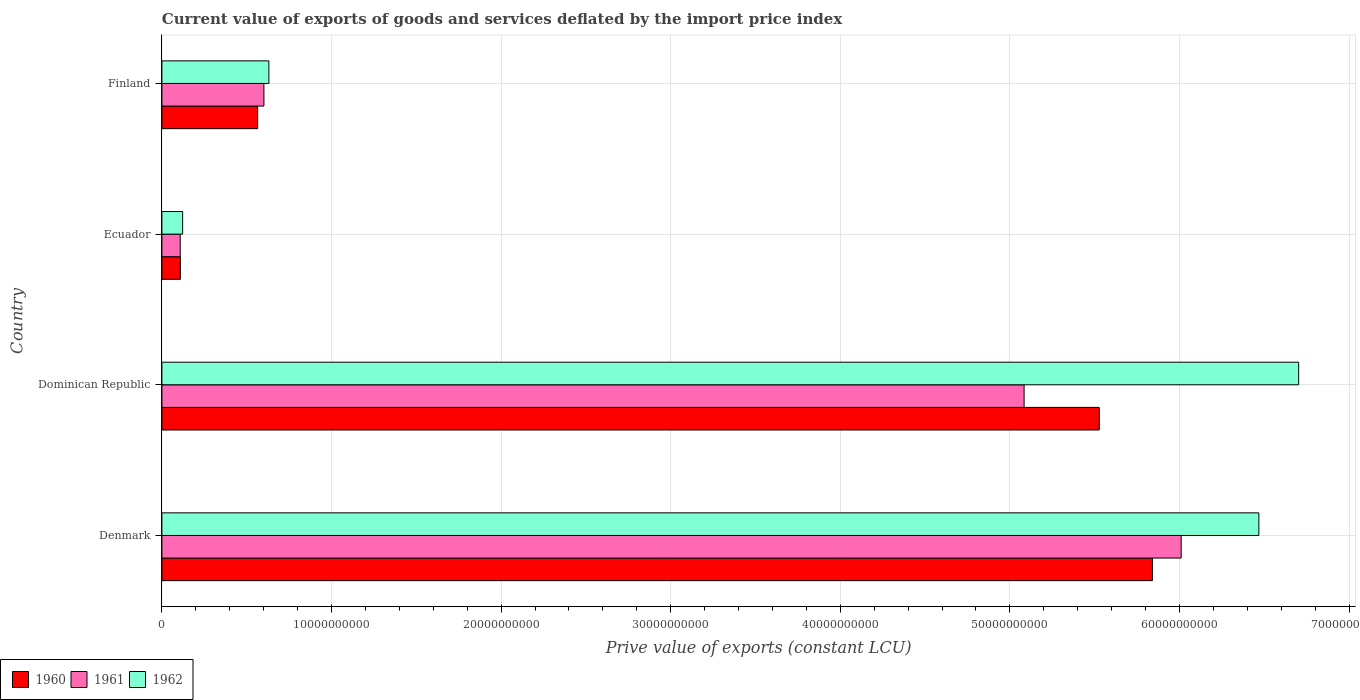How many bars are there on the 2nd tick from the bottom?
Keep it short and to the point. 3. In how many cases, is the number of bars for a given country not equal to the number of legend labels?
Your answer should be very brief. 0. What is the prive value of exports in 1962 in Denmark?
Your answer should be very brief. 6.47e+1. Across all countries, what is the maximum prive value of exports in 1962?
Offer a very short reply. 6.70e+1. Across all countries, what is the minimum prive value of exports in 1961?
Ensure brevity in your answer.  1.08e+09. In which country was the prive value of exports in 1961 minimum?
Provide a short and direct response. Ecuador. What is the total prive value of exports in 1961 in the graph?
Your answer should be very brief. 1.18e+11. What is the difference between the prive value of exports in 1960 in Denmark and that in Ecuador?
Offer a very short reply. 5.73e+1. What is the difference between the prive value of exports in 1961 in Finland and the prive value of exports in 1960 in Dominican Republic?
Your answer should be compact. -4.93e+1. What is the average prive value of exports in 1961 per country?
Give a very brief answer. 2.95e+1. What is the difference between the prive value of exports in 1962 and prive value of exports in 1960 in Dominican Republic?
Give a very brief answer. 1.18e+1. In how many countries, is the prive value of exports in 1962 greater than 68000000000 LCU?
Your answer should be very brief. 0. What is the ratio of the prive value of exports in 1961 in Denmark to that in Finland?
Offer a very short reply. 9.99. Is the prive value of exports in 1962 in Denmark less than that in Dominican Republic?
Provide a short and direct response. Yes. What is the difference between the highest and the second highest prive value of exports in 1961?
Provide a short and direct response. 9.26e+09. What is the difference between the highest and the lowest prive value of exports in 1962?
Keep it short and to the point. 6.58e+1. Is the sum of the prive value of exports in 1961 in Denmark and Dominican Republic greater than the maximum prive value of exports in 1962 across all countries?
Provide a short and direct response. Yes. What does the 2nd bar from the top in Finland represents?
Your answer should be compact. 1961. What does the 2nd bar from the bottom in Dominican Republic represents?
Your answer should be compact. 1961. Are all the bars in the graph horizontal?
Offer a very short reply. Yes. What is the difference between two consecutive major ticks on the X-axis?
Make the answer very short. 1.00e+1. Are the values on the major ticks of X-axis written in scientific E-notation?
Your answer should be very brief. No. Does the graph contain any zero values?
Provide a short and direct response. No. Does the graph contain grids?
Offer a terse response. Yes. Where does the legend appear in the graph?
Ensure brevity in your answer.  Bottom left. How many legend labels are there?
Make the answer very short. 3. What is the title of the graph?
Offer a terse response. Current value of exports of goods and services deflated by the import price index. What is the label or title of the X-axis?
Provide a short and direct response. Prive value of exports (constant LCU). What is the label or title of the Y-axis?
Keep it short and to the point. Country. What is the Prive value of exports (constant LCU) of 1960 in Denmark?
Provide a short and direct response. 5.84e+1. What is the Prive value of exports (constant LCU) of 1961 in Denmark?
Provide a succinct answer. 6.01e+1. What is the Prive value of exports (constant LCU) of 1962 in Denmark?
Offer a very short reply. 6.47e+1. What is the Prive value of exports (constant LCU) of 1960 in Dominican Republic?
Provide a short and direct response. 5.53e+1. What is the Prive value of exports (constant LCU) in 1961 in Dominican Republic?
Your response must be concise. 5.08e+1. What is the Prive value of exports (constant LCU) in 1962 in Dominican Republic?
Give a very brief answer. 6.70e+1. What is the Prive value of exports (constant LCU) in 1960 in Ecuador?
Offer a very short reply. 1.09e+09. What is the Prive value of exports (constant LCU) in 1961 in Ecuador?
Provide a short and direct response. 1.08e+09. What is the Prive value of exports (constant LCU) in 1962 in Ecuador?
Your answer should be compact. 1.22e+09. What is the Prive value of exports (constant LCU) of 1960 in Finland?
Your response must be concise. 5.65e+09. What is the Prive value of exports (constant LCU) of 1961 in Finland?
Your answer should be very brief. 6.02e+09. What is the Prive value of exports (constant LCU) of 1962 in Finland?
Your answer should be very brief. 6.31e+09. Across all countries, what is the maximum Prive value of exports (constant LCU) of 1960?
Your answer should be compact. 5.84e+1. Across all countries, what is the maximum Prive value of exports (constant LCU) of 1961?
Provide a short and direct response. 6.01e+1. Across all countries, what is the maximum Prive value of exports (constant LCU) of 1962?
Give a very brief answer. 6.70e+1. Across all countries, what is the minimum Prive value of exports (constant LCU) of 1960?
Offer a terse response. 1.09e+09. Across all countries, what is the minimum Prive value of exports (constant LCU) in 1961?
Give a very brief answer. 1.08e+09. Across all countries, what is the minimum Prive value of exports (constant LCU) in 1962?
Your answer should be very brief. 1.22e+09. What is the total Prive value of exports (constant LCU) in 1960 in the graph?
Your response must be concise. 1.20e+11. What is the total Prive value of exports (constant LCU) in 1961 in the graph?
Keep it short and to the point. 1.18e+11. What is the total Prive value of exports (constant LCU) in 1962 in the graph?
Your answer should be compact. 1.39e+11. What is the difference between the Prive value of exports (constant LCU) of 1960 in Denmark and that in Dominican Republic?
Offer a very short reply. 3.13e+09. What is the difference between the Prive value of exports (constant LCU) of 1961 in Denmark and that in Dominican Republic?
Give a very brief answer. 9.26e+09. What is the difference between the Prive value of exports (constant LCU) in 1962 in Denmark and that in Dominican Republic?
Your response must be concise. -2.35e+09. What is the difference between the Prive value of exports (constant LCU) in 1960 in Denmark and that in Ecuador?
Make the answer very short. 5.73e+1. What is the difference between the Prive value of exports (constant LCU) of 1961 in Denmark and that in Ecuador?
Your answer should be very brief. 5.90e+1. What is the difference between the Prive value of exports (constant LCU) in 1962 in Denmark and that in Ecuador?
Your response must be concise. 6.35e+1. What is the difference between the Prive value of exports (constant LCU) in 1960 in Denmark and that in Finland?
Keep it short and to the point. 5.28e+1. What is the difference between the Prive value of exports (constant LCU) in 1961 in Denmark and that in Finland?
Offer a terse response. 5.41e+1. What is the difference between the Prive value of exports (constant LCU) in 1962 in Denmark and that in Finland?
Provide a succinct answer. 5.84e+1. What is the difference between the Prive value of exports (constant LCU) in 1960 in Dominican Republic and that in Ecuador?
Offer a terse response. 5.42e+1. What is the difference between the Prive value of exports (constant LCU) in 1961 in Dominican Republic and that in Ecuador?
Offer a terse response. 4.98e+1. What is the difference between the Prive value of exports (constant LCU) in 1962 in Dominican Republic and that in Ecuador?
Your answer should be very brief. 6.58e+1. What is the difference between the Prive value of exports (constant LCU) of 1960 in Dominican Republic and that in Finland?
Ensure brevity in your answer.  4.96e+1. What is the difference between the Prive value of exports (constant LCU) of 1961 in Dominican Republic and that in Finland?
Your answer should be very brief. 4.48e+1. What is the difference between the Prive value of exports (constant LCU) in 1962 in Dominican Republic and that in Finland?
Make the answer very short. 6.07e+1. What is the difference between the Prive value of exports (constant LCU) in 1960 in Ecuador and that in Finland?
Your response must be concise. -4.56e+09. What is the difference between the Prive value of exports (constant LCU) of 1961 in Ecuador and that in Finland?
Your answer should be compact. -4.94e+09. What is the difference between the Prive value of exports (constant LCU) in 1962 in Ecuador and that in Finland?
Your answer should be compact. -5.09e+09. What is the difference between the Prive value of exports (constant LCU) of 1960 in Denmark and the Prive value of exports (constant LCU) of 1961 in Dominican Republic?
Give a very brief answer. 7.57e+09. What is the difference between the Prive value of exports (constant LCU) in 1960 in Denmark and the Prive value of exports (constant LCU) in 1962 in Dominican Republic?
Ensure brevity in your answer.  -8.62e+09. What is the difference between the Prive value of exports (constant LCU) in 1961 in Denmark and the Prive value of exports (constant LCU) in 1962 in Dominican Republic?
Make the answer very short. -6.93e+09. What is the difference between the Prive value of exports (constant LCU) of 1960 in Denmark and the Prive value of exports (constant LCU) of 1961 in Ecuador?
Provide a short and direct response. 5.73e+1. What is the difference between the Prive value of exports (constant LCU) of 1960 in Denmark and the Prive value of exports (constant LCU) of 1962 in Ecuador?
Your answer should be compact. 5.72e+1. What is the difference between the Prive value of exports (constant LCU) of 1961 in Denmark and the Prive value of exports (constant LCU) of 1962 in Ecuador?
Ensure brevity in your answer.  5.89e+1. What is the difference between the Prive value of exports (constant LCU) of 1960 in Denmark and the Prive value of exports (constant LCU) of 1961 in Finland?
Make the answer very short. 5.24e+1. What is the difference between the Prive value of exports (constant LCU) of 1960 in Denmark and the Prive value of exports (constant LCU) of 1962 in Finland?
Ensure brevity in your answer.  5.21e+1. What is the difference between the Prive value of exports (constant LCU) in 1961 in Denmark and the Prive value of exports (constant LCU) in 1962 in Finland?
Provide a short and direct response. 5.38e+1. What is the difference between the Prive value of exports (constant LCU) in 1960 in Dominican Republic and the Prive value of exports (constant LCU) in 1961 in Ecuador?
Keep it short and to the point. 5.42e+1. What is the difference between the Prive value of exports (constant LCU) of 1960 in Dominican Republic and the Prive value of exports (constant LCU) of 1962 in Ecuador?
Ensure brevity in your answer.  5.40e+1. What is the difference between the Prive value of exports (constant LCU) in 1961 in Dominican Republic and the Prive value of exports (constant LCU) in 1962 in Ecuador?
Make the answer very short. 4.96e+1. What is the difference between the Prive value of exports (constant LCU) in 1960 in Dominican Republic and the Prive value of exports (constant LCU) in 1961 in Finland?
Your answer should be very brief. 4.93e+1. What is the difference between the Prive value of exports (constant LCU) of 1960 in Dominican Republic and the Prive value of exports (constant LCU) of 1962 in Finland?
Your answer should be compact. 4.90e+1. What is the difference between the Prive value of exports (constant LCU) in 1961 in Dominican Republic and the Prive value of exports (constant LCU) in 1962 in Finland?
Provide a short and direct response. 4.45e+1. What is the difference between the Prive value of exports (constant LCU) of 1960 in Ecuador and the Prive value of exports (constant LCU) of 1961 in Finland?
Make the answer very short. -4.93e+09. What is the difference between the Prive value of exports (constant LCU) of 1960 in Ecuador and the Prive value of exports (constant LCU) of 1962 in Finland?
Ensure brevity in your answer.  -5.22e+09. What is the difference between the Prive value of exports (constant LCU) of 1961 in Ecuador and the Prive value of exports (constant LCU) of 1962 in Finland?
Make the answer very short. -5.23e+09. What is the average Prive value of exports (constant LCU) in 1960 per country?
Offer a very short reply. 3.01e+1. What is the average Prive value of exports (constant LCU) in 1961 per country?
Offer a terse response. 2.95e+1. What is the average Prive value of exports (constant LCU) in 1962 per country?
Offer a terse response. 3.48e+1. What is the difference between the Prive value of exports (constant LCU) of 1960 and Prive value of exports (constant LCU) of 1961 in Denmark?
Give a very brief answer. -1.70e+09. What is the difference between the Prive value of exports (constant LCU) of 1960 and Prive value of exports (constant LCU) of 1962 in Denmark?
Your answer should be very brief. -6.28e+09. What is the difference between the Prive value of exports (constant LCU) in 1961 and Prive value of exports (constant LCU) in 1962 in Denmark?
Your response must be concise. -4.58e+09. What is the difference between the Prive value of exports (constant LCU) of 1960 and Prive value of exports (constant LCU) of 1961 in Dominican Republic?
Offer a very short reply. 4.43e+09. What is the difference between the Prive value of exports (constant LCU) of 1960 and Prive value of exports (constant LCU) of 1962 in Dominican Republic?
Provide a short and direct response. -1.18e+1. What is the difference between the Prive value of exports (constant LCU) of 1961 and Prive value of exports (constant LCU) of 1962 in Dominican Republic?
Offer a terse response. -1.62e+1. What is the difference between the Prive value of exports (constant LCU) of 1960 and Prive value of exports (constant LCU) of 1961 in Ecuador?
Provide a succinct answer. 7.73e+06. What is the difference between the Prive value of exports (constant LCU) of 1960 and Prive value of exports (constant LCU) of 1962 in Ecuador?
Make the answer very short. -1.34e+08. What is the difference between the Prive value of exports (constant LCU) in 1961 and Prive value of exports (constant LCU) in 1962 in Ecuador?
Ensure brevity in your answer.  -1.41e+08. What is the difference between the Prive value of exports (constant LCU) in 1960 and Prive value of exports (constant LCU) in 1961 in Finland?
Your answer should be compact. -3.69e+08. What is the difference between the Prive value of exports (constant LCU) in 1960 and Prive value of exports (constant LCU) in 1962 in Finland?
Your answer should be compact. -6.62e+08. What is the difference between the Prive value of exports (constant LCU) of 1961 and Prive value of exports (constant LCU) of 1962 in Finland?
Make the answer very short. -2.93e+08. What is the ratio of the Prive value of exports (constant LCU) in 1960 in Denmark to that in Dominican Republic?
Give a very brief answer. 1.06. What is the ratio of the Prive value of exports (constant LCU) of 1961 in Denmark to that in Dominican Republic?
Your answer should be compact. 1.18. What is the ratio of the Prive value of exports (constant LCU) in 1962 in Denmark to that in Dominican Republic?
Provide a short and direct response. 0.96. What is the ratio of the Prive value of exports (constant LCU) in 1960 in Denmark to that in Ecuador?
Offer a very short reply. 53.67. What is the ratio of the Prive value of exports (constant LCU) in 1961 in Denmark to that in Ecuador?
Offer a terse response. 55.63. What is the ratio of the Prive value of exports (constant LCU) in 1962 in Denmark to that in Ecuador?
Provide a short and direct response. 52.94. What is the ratio of the Prive value of exports (constant LCU) in 1960 in Denmark to that in Finland?
Give a very brief answer. 10.34. What is the ratio of the Prive value of exports (constant LCU) in 1961 in Denmark to that in Finland?
Make the answer very short. 9.99. What is the ratio of the Prive value of exports (constant LCU) of 1962 in Denmark to that in Finland?
Provide a succinct answer. 10.25. What is the ratio of the Prive value of exports (constant LCU) of 1960 in Dominican Republic to that in Ecuador?
Provide a succinct answer. 50.79. What is the ratio of the Prive value of exports (constant LCU) of 1961 in Dominican Republic to that in Ecuador?
Give a very brief answer. 47.06. What is the ratio of the Prive value of exports (constant LCU) of 1962 in Dominican Republic to that in Ecuador?
Make the answer very short. 54.86. What is the ratio of the Prive value of exports (constant LCU) of 1960 in Dominican Republic to that in Finland?
Your answer should be compact. 9.79. What is the ratio of the Prive value of exports (constant LCU) of 1961 in Dominican Republic to that in Finland?
Your response must be concise. 8.45. What is the ratio of the Prive value of exports (constant LCU) of 1962 in Dominican Republic to that in Finland?
Make the answer very short. 10.62. What is the ratio of the Prive value of exports (constant LCU) of 1960 in Ecuador to that in Finland?
Ensure brevity in your answer.  0.19. What is the ratio of the Prive value of exports (constant LCU) of 1961 in Ecuador to that in Finland?
Make the answer very short. 0.18. What is the ratio of the Prive value of exports (constant LCU) of 1962 in Ecuador to that in Finland?
Provide a short and direct response. 0.19. What is the difference between the highest and the second highest Prive value of exports (constant LCU) in 1960?
Your answer should be very brief. 3.13e+09. What is the difference between the highest and the second highest Prive value of exports (constant LCU) of 1961?
Keep it short and to the point. 9.26e+09. What is the difference between the highest and the second highest Prive value of exports (constant LCU) in 1962?
Provide a short and direct response. 2.35e+09. What is the difference between the highest and the lowest Prive value of exports (constant LCU) of 1960?
Provide a succinct answer. 5.73e+1. What is the difference between the highest and the lowest Prive value of exports (constant LCU) of 1961?
Give a very brief answer. 5.90e+1. What is the difference between the highest and the lowest Prive value of exports (constant LCU) in 1962?
Offer a very short reply. 6.58e+1. 